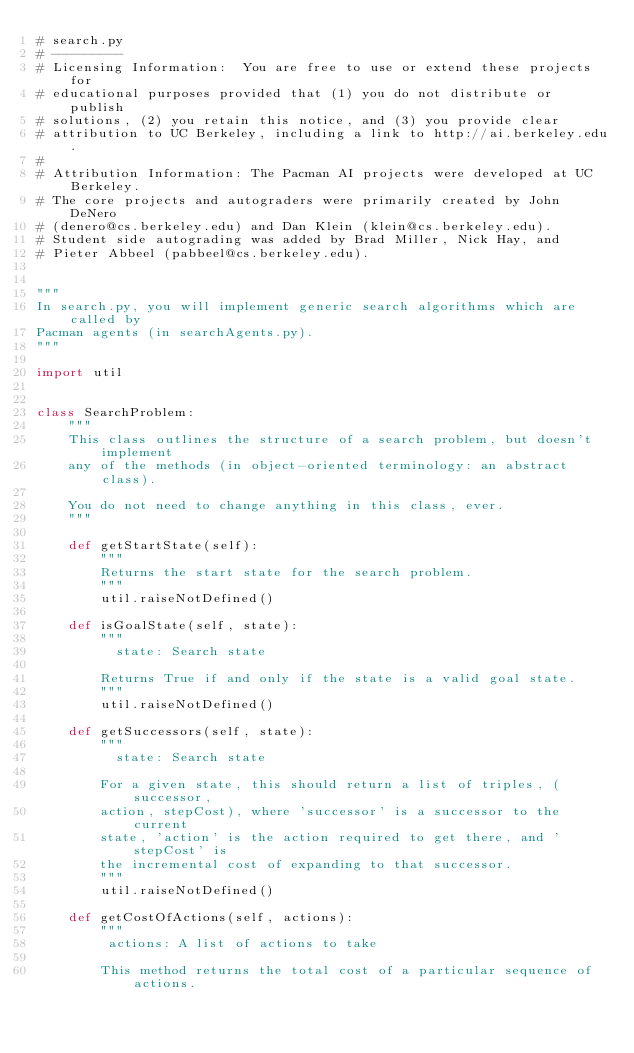Convert code to text. <code><loc_0><loc_0><loc_500><loc_500><_Python_># search.py
# ---------
# Licensing Information:  You are free to use or extend these projects for
# educational purposes provided that (1) you do not distribute or publish
# solutions, (2) you retain this notice, and (3) you provide clear
# attribution to UC Berkeley, including a link to http://ai.berkeley.edu.
#
# Attribution Information: The Pacman AI projects were developed at UC Berkeley.
# The core projects and autograders were primarily created by John DeNero
# (denero@cs.berkeley.edu) and Dan Klein (klein@cs.berkeley.edu).
# Student side autograding was added by Brad Miller, Nick Hay, and
# Pieter Abbeel (pabbeel@cs.berkeley.edu).


"""
In search.py, you will implement generic search algorithms which are called by
Pacman agents (in searchAgents.py).
"""

import util


class SearchProblem:
    """
    This class outlines the structure of a search problem, but doesn't implement
    any of the methods (in object-oriented terminology: an abstract class).

    You do not need to change anything in this class, ever.
    """

    def getStartState(self):
        """
        Returns the start state for the search problem.
        """
        util.raiseNotDefined()

    def isGoalState(self, state):
        """
          state: Search state

        Returns True if and only if the state is a valid goal state.
        """
        util.raiseNotDefined()

    def getSuccessors(self, state):
        """
          state: Search state

        For a given state, this should return a list of triples, (successor,
        action, stepCost), where 'successor' is a successor to the current
        state, 'action' is the action required to get there, and 'stepCost' is
        the incremental cost of expanding to that successor.
        """
        util.raiseNotDefined()

    def getCostOfActions(self, actions):
        """
         actions: A list of actions to take

        This method returns the total cost of a particular sequence of actions.</code> 